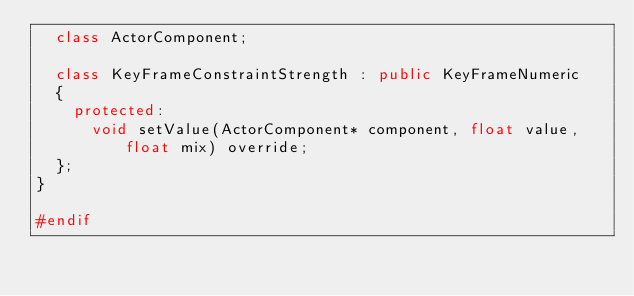Convert code to text. <code><loc_0><loc_0><loc_500><loc_500><_C++_>	class ActorComponent;

	class KeyFrameConstraintStrength : public KeyFrameNumeric
	{
		protected:
			void setValue(ActorComponent* component, float value, float mix) override;
	};
}

#endif</code> 